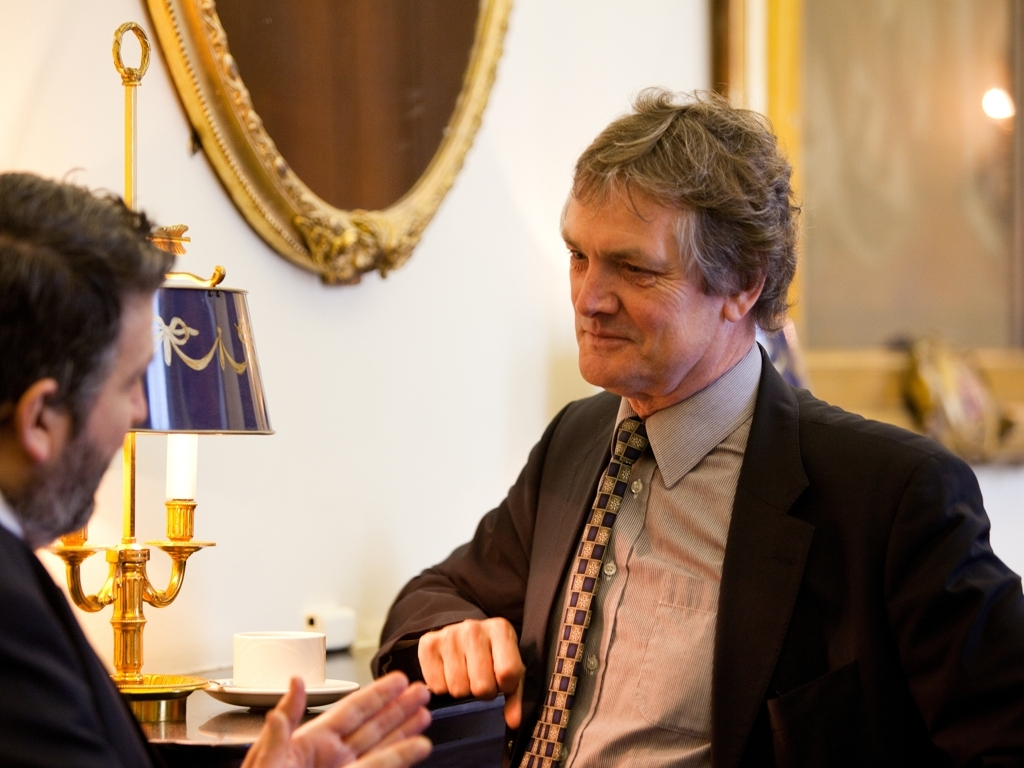What are the colors like in the image?
A. Pale
B. Dull
C. Rich
Answer with the option's letter from the given choices directly. The colors in the image convey a sense of richness, given the warm and vivid tones present throughout the scene. The golden hues of the lamp, the deep blue shade of the lampshade, and the attire of the individuals suggest an environment that is sophisticated and vibrant. Therefore, the most appropriate answer to the question would be 'C. Rich'. 